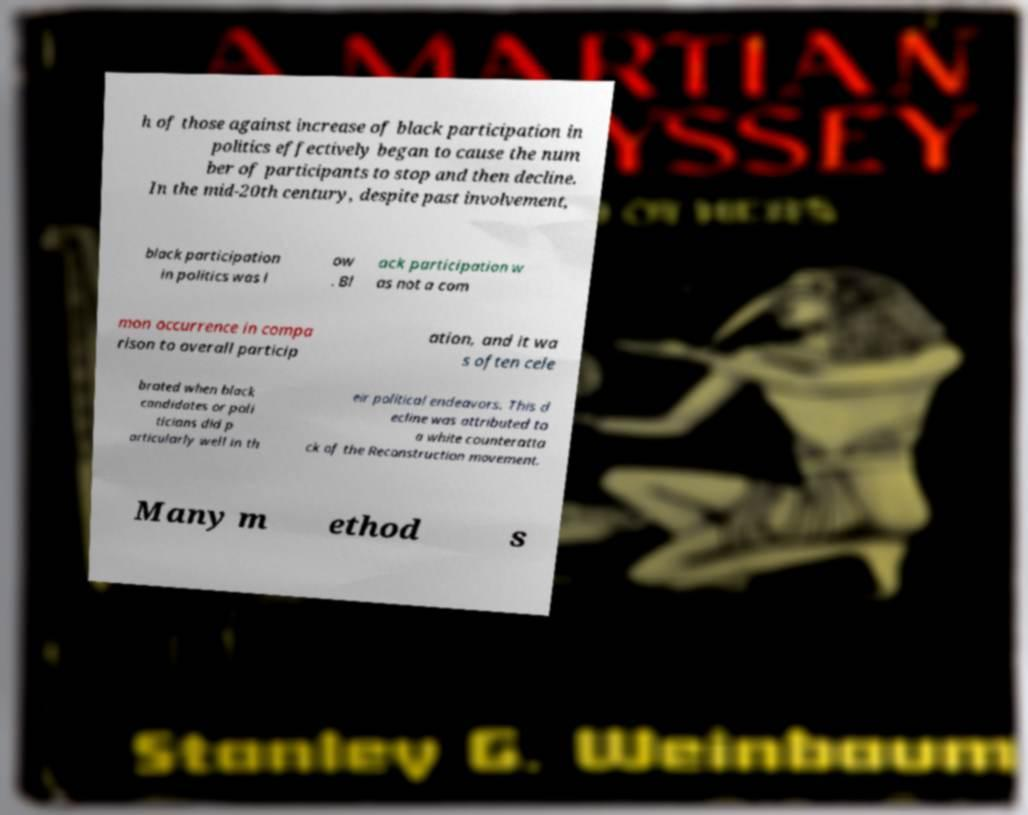Please read and relay the text visible in this image. What does it say? h of those against increase of black participation in politics effectively began to cause the num ber of participants to stop and then decline. In the mid-20th century, despite past involvement, black participation in politics was l ow . Bl ack participation w as not a com mon occurrence in compa rison to overall particip ation, and it wa s often cele brated when black candidates or poli ticians did p articularly well in th eir political endeavors. This d ecline was attributed to a white counteratta ck of the Reconstruction movement. Many m ethod s 